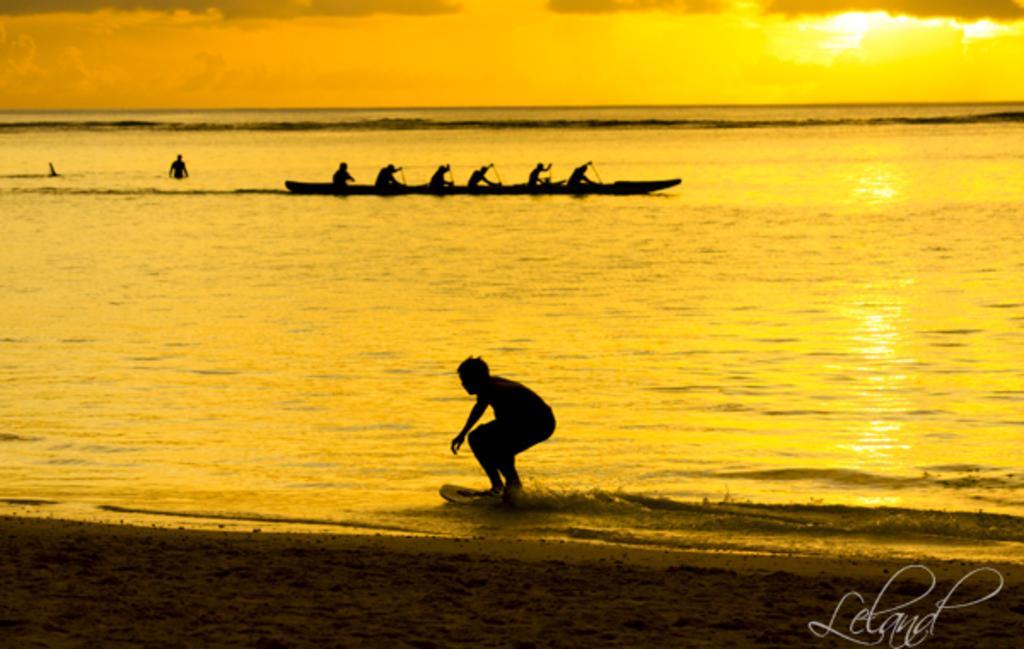Could you give a brief overview of what you see in this image? This is an outside view. At the bottom of the image I can see the sand. In the middle of the image I can see an ocean. In the foreground a person is surfing the board on the water. In the background there is a boat on which few people are sitting by holding paddles in the hands. At the top of the image I can see the sky. 